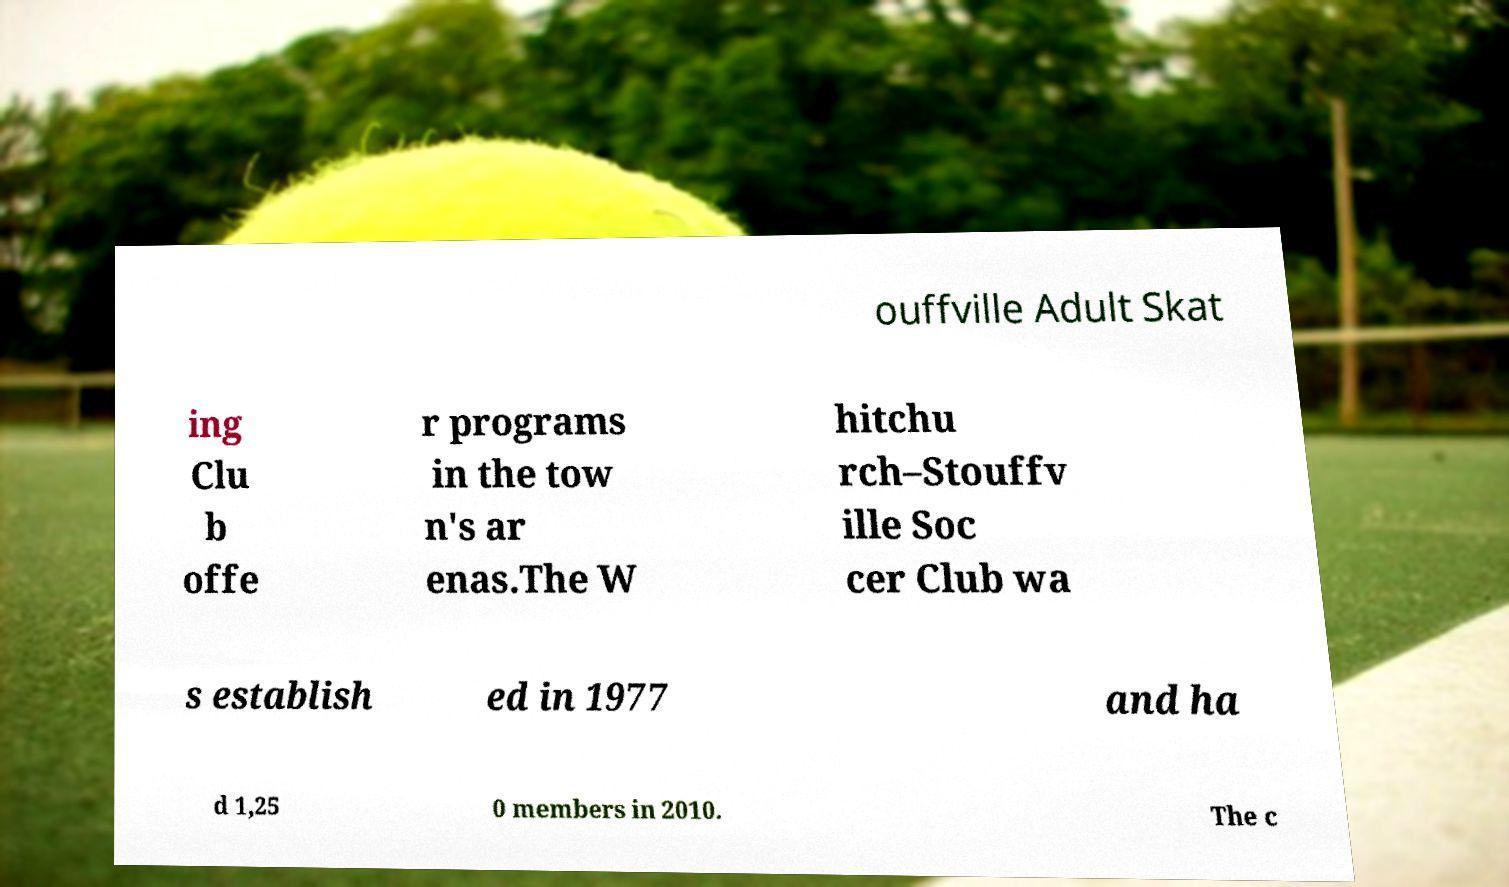I need the written content from this picture converted into text. Can you do that? ouffville Adult Skat ing Clu b offe r programs in the tow n's ar enas.The W hitchu rch–Stouffv ille Soc cer Club wa s establish ed in 1977 and ha d 1,25 0 members in 2010. The c 